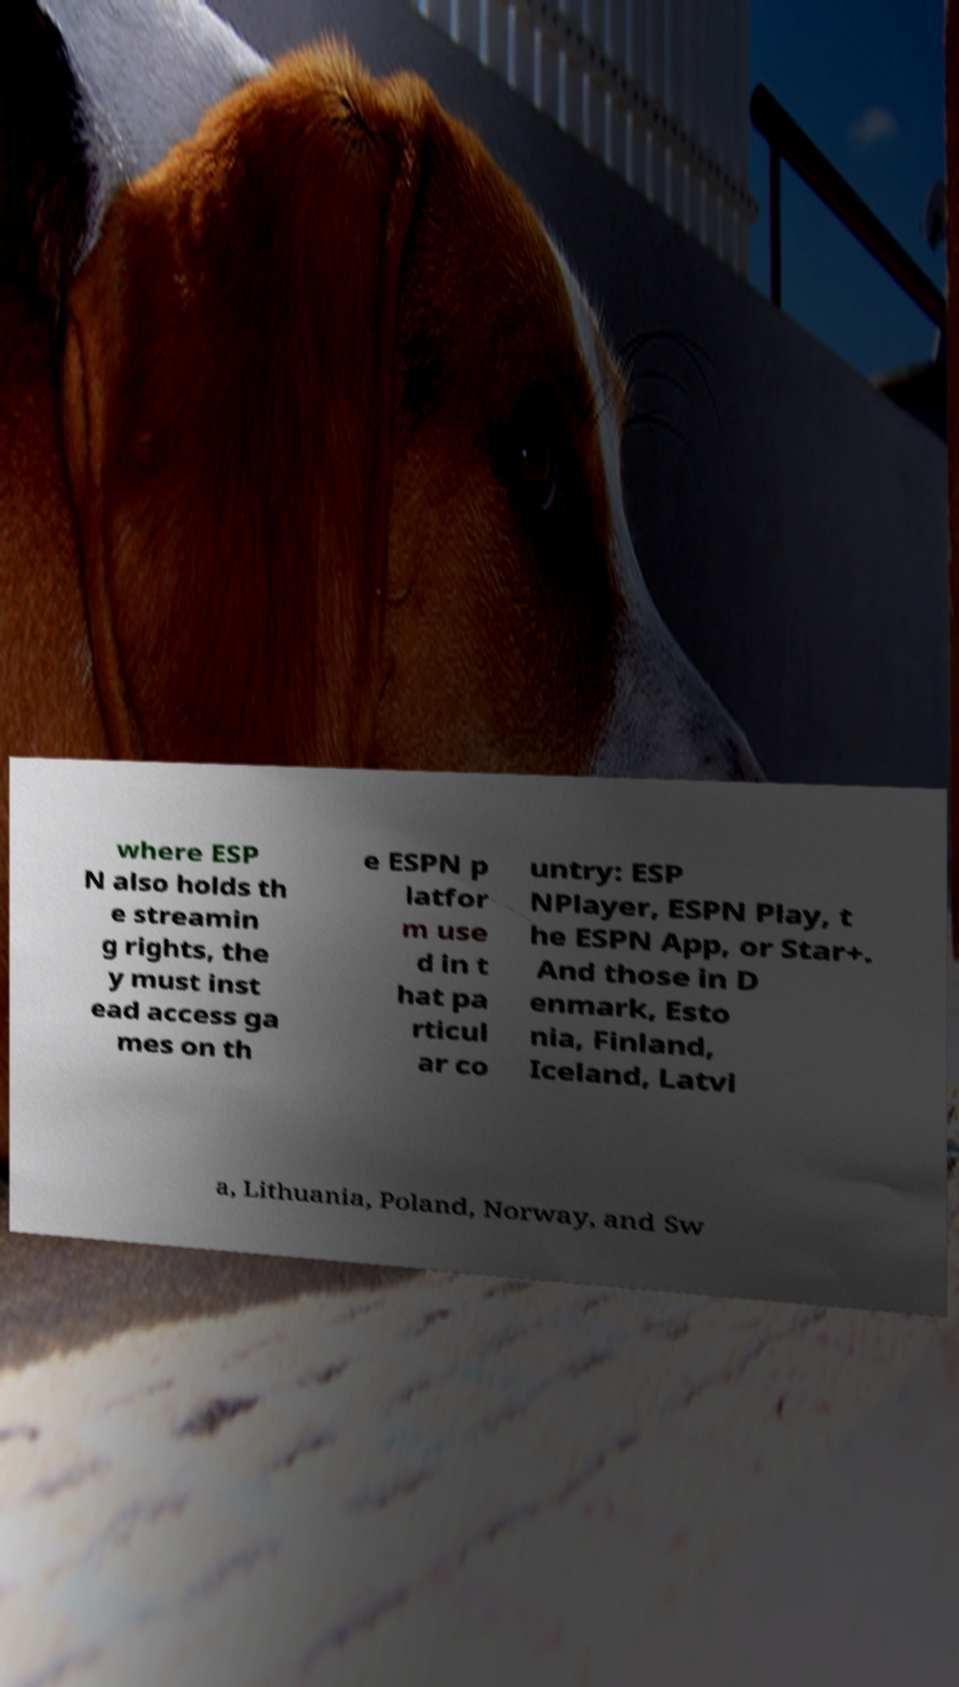For documentation purposes, I need the text within this image transcribed. Could you provide that? where ESP N also holds th e streamin g rights, the y must inst ead access ga mes on th e ESPN p latfor m use d in t hat pa rticul ar co untry: ESP NPlayer, ESPN Play, t he ESPN App, or Star+. And those in D enmark, Esto nia, Finland, Iceland, Latvi a, Lithuania, Poland, Norway, and Sw 